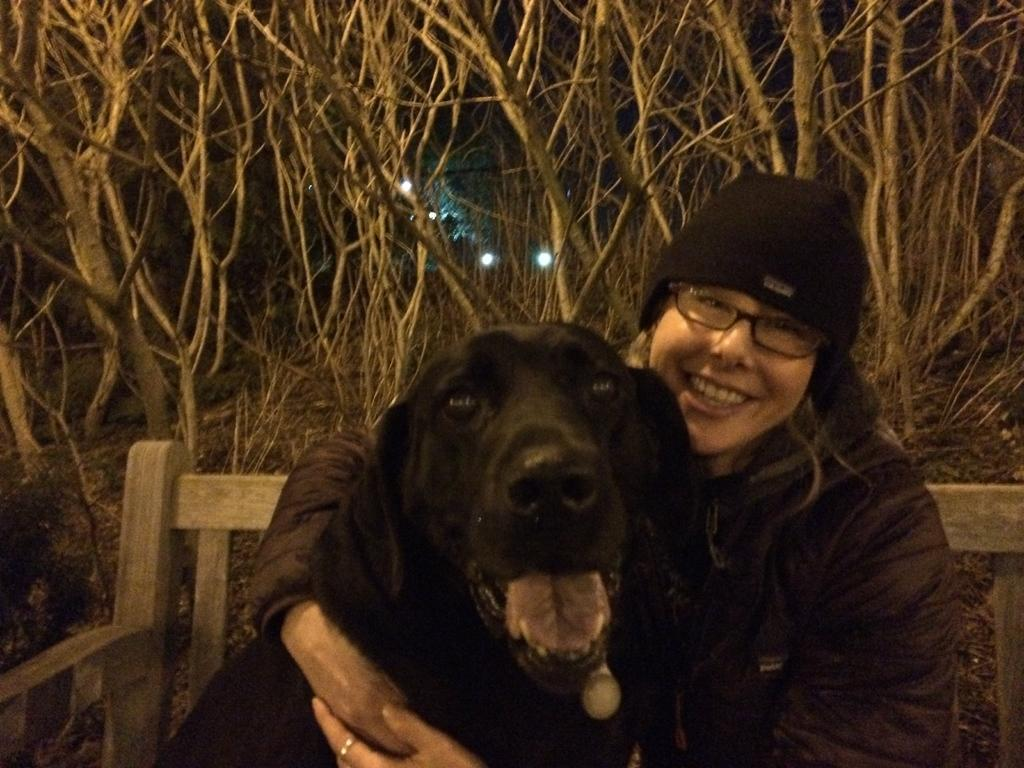Who is present in the image? There is a woman in the image. What type of animal is with the woman? There is a black color dog in the image. Where are the woman and the dog sitting? The woman and the dog are sitting on a bench. What can be seen in the background of the image? There are dry trees in the background of the image. Can you describe the curve in the road where the fight between the two towns took place? There is no mention of a road, fight, or two towns in the image. The image features a woman, a black dog, and dry trees in the background. 